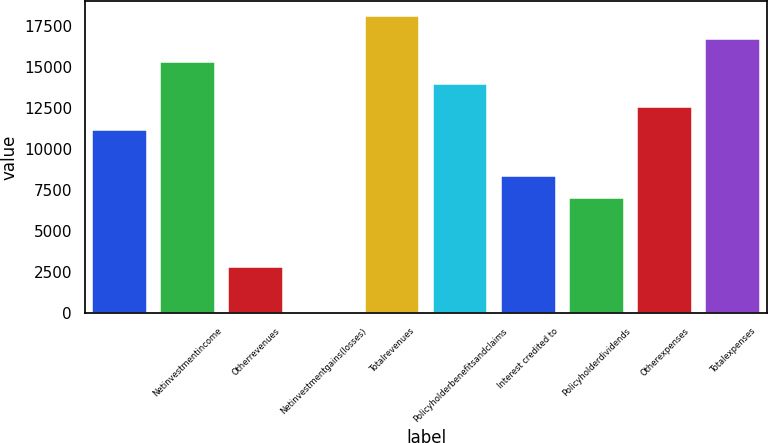Convert chart. <chart><loc_0><loc_0><loc_500><loc_500><bar_chart><ecel><fcel>Netinvestmentincome<fcel>Otherrevenues<fcel>Netinvestmentgains(losses)<fcel>Totalrevenues<fcel>Policyholderbenefitsandclaims<fcel>Interest credited to<fcel>Policyholderdividends<fcel>Otherexpenses<fcel>Totalexpenses<nl><fcel>11147.6<fcel>15309.2<fcel>2824.4<fcel>50<fcel>18083.6<fcel>13922<fcel>8373.2<fcel>6986<fcel>12534.8<fcel>16696.4<nl></chart> 